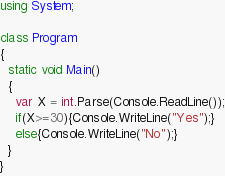Convert code to text. <code><loc_0><loc_0><loc_500><loc_500><_C#_>using System;

class Program
{
  static void Main()
  {
  	var X = int.Parse(Console.ReadLine());
    if(X>=30){Console.WriteLine("Yes");}
    else{Console.WriteLine("No");}
  }
}</code> 